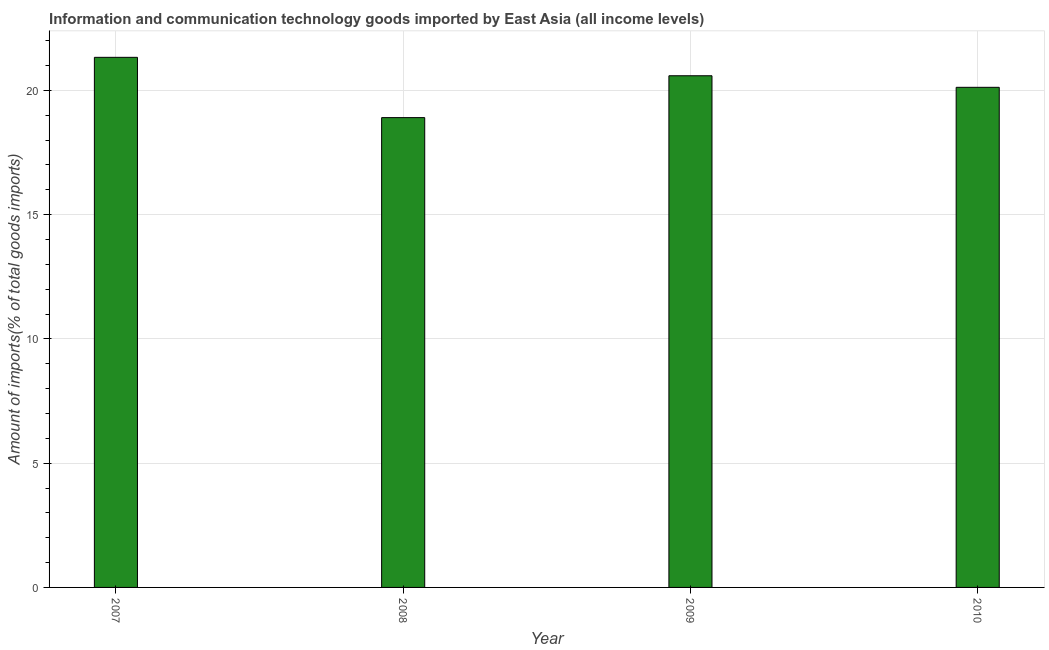Does the graph contain any zero values?
Offer a very short reply. No. What is the title of the graph?
Give a very brief answer. Information and communication technology goods imported by East Asia (all income levels). What is the label or title of the X-axis?
Give a very brief answer. Year. What is the label or title of the Y-axis?
Give a very brief answer. Amount of imports(% of total goods imports). What is the amount of ict goods imports in 2007?
Offer a terse response. 21.33. Across all years, what is the maximum amount of ict goods imports?
Keep it short and to the point. 21.33. Across all years, what is the minimum amount of ict goods imports?
Give a very brief answer. 18.9. What is the sum of the amount of ict goods imports?
Keep it short and to the point. 80.95. What is the difference between the amount of ict goods imports in 2008 and 2009?
Keep it short and to the point. -1.69. What is the average amount of ict goods imports per year?
Your answer should be very brief. 20.24. What is the median amount of ict goods imports?
Offer a very short reply. 20.36. In how many years, is the amount of ict goods imports greater than 10 %?
Keep it short and to the point. 4. Do a majority of the years between 2010 and 2007 (inclusive) have amount of ict goods imports greater than 16 %?
Provide a succinct answer. Yes. What is the ratio of the amount of ict goods imports in 2008 to that in 2009?
Your answer should be very brief. 0.92. Is the difference between the amount of ict goods imports in 2007 and 2008 greater than the difference between any two years?
Ensure brevity in your answer.  Yes. What is the difference between the highest and the second highest amount of ict goods imports?
Make the answer very short. 0.74. What is the difference between the highest and the lowest amount of ict goods imports?
Offer a very short reply. 2.43. How many bars are there?
Provide a succinct answer. 4. What is the Amount of imports(% of total goods imports) in 2007?
Provide a succinct answer. 21.33. What is the Amount of imports(% of total goods imports) of 2008?
Your answer should be very brief. 18.9. What is the Amount of imports(% of total goods imports) in 2009?
Your response must be concise. 20.59. What is the Amount of imports(% of total goods imports) in 2010?
Give a very brief answer. 20.12. What is the difference between the Amount of imports(% of total goods imports) in 2007 and 2008?
Offer a very short reply. 2.43. What is the difference between the Amount of imports(% of total goods imports) in 2007 and 2009?
Offer a very short reply. 0.74. What is the difference between the Amount of imports(% of total goods imports) in 2007 and 2010?
Offer a terse response. 1.21. What is the difference between the Amount of imports(% of total goods imports) in 2008 and 2009?
Ensure brevity in your answer.  -1.68. What is the difference between the Amount of imports(% of total goods imports) in 2008 and 2010?
Make the answer very short. -1.22. What is the difference between the Amount of imports(% of total goods imports) in 2009 and 2010?
Your response must be concise. 0.47. What is the ratio of the Amount of imports(% of total goods imports) in 2007 to that in 2008?
Keep it short and to the point. 1.13. What is the ratio of the Amount of imports(% of total goods imports) in 2007 to that in 2009?
Give a very brief answer. 1.04. What is the ratio of the Amount of imports(% of total goods imports) in 2007 to that in 2010?
Your response must be concise. 1.06. What is the ratio of the Amount of imports(% of total goods imports) in 2008 to that in 2009?
Provide a succinct answer. 0.92. What is the ratio of the Amount of imports(% of total goods imports) in 2008 to that in 2010?
Offer a very short reply. 0.94. 